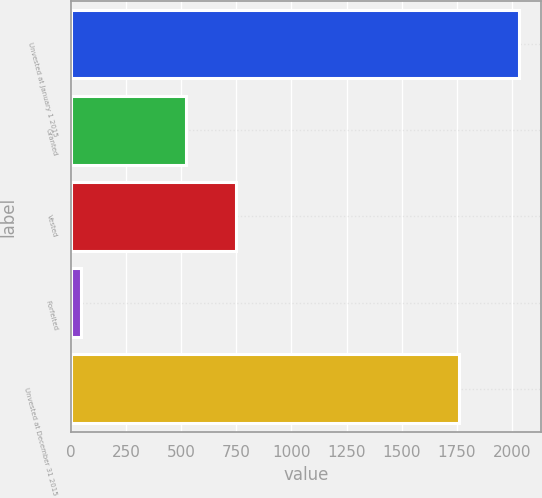Convert chart. <chart><loc_0><loc_0><loc_500><loc_500><bar_chart><fcel>Unvested at January 1 2015<fcel>Granted<fcel>Vested<fcel>Forfeited<fcel>Unvested at December 31 2015<nl><fcel>2033<fcel>523<fcel>749<fcel>45<fcel>1762<nl></chart> 